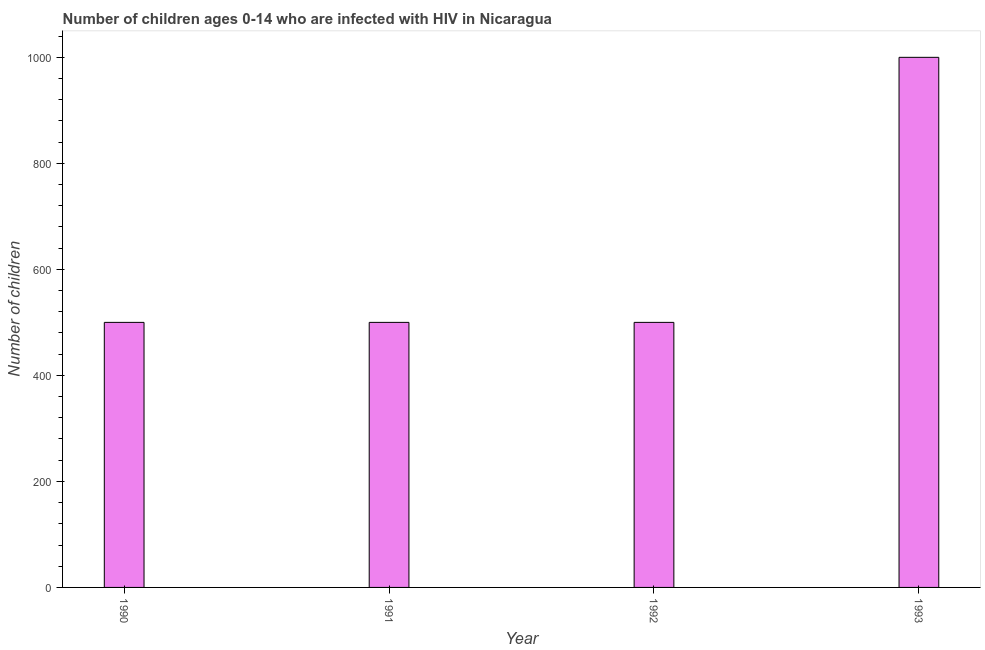Does the graph contain grids?
Keep it short and to the point. No. What is the title of the graph?
Provide a succinct answer. Number of children ages 0-14 who are infected with HIV in Nicaragua. What is the label or title of the Y-axis?
Your answer should be very brief. Number of children. What is the number of children living with hiv in 1991?
Ensure brevity in your answer.  500. Across all years, what is the minimum number of children living with hiv?
Your answer should be compact. 500. What is the sum of the number of children living with hiv?
Provide a succinct answer. 2500. What is the difference between the number of children living with hiv in 1991 and 1992?
Ensure brevity in your answer.  0. What is the average number of children living with hiv per year?
Keep it short and to the point. 625. What is the median number of children living with hiv?
Your response must be concise. 500. Do a majority of the years between 1991 and 1990 (inclusive) have number of children living with hiv greater than 960 ?
Your answer should be compact. No. Is the difference between the number of children living with hiv in 1990 and 1991 greater than the difference between any two years?
Your answer should be compact. No. What is the difference between the highest and the second highest number of children living with hiv?
Your answer should be compact. 500. Is the sum of the number of children living with hiv in 1991 and 1993 greater than the maximum number of children living with hiv across all years?
Give a very brief answer. Yes. What is the difference between the highest and the lowest number of children living with hiv?
Give a very brief answer. 500. How many bars are there?
Give a very brief answer. 4. Are all the bars in the graph horizontal?
Offer a terse response. No. What is the difference between two consecutive major ticks on the Y-axis?
Keep it short and to the point. 200. Are the values on the major ticks of Y-axis written in scientific E-notation?
Offer a very short reply. No. What is the Number of children in 1990?
Offer a terse response. 500. What is the Number of children of 1991?
Ensure brevity in your answer.  500. What is the Number of children of 1992?
Ensure brevity in your answer.  500. What is the difference between the Number of children in 1990 and 1993?
Offer a very short reply. -500. What is the difference between the Number of children in 1991 and 1993?
Offer a very short reply. -500. What is the difference between the Number of children in 1992 and 1993?
Give a very brief answer. -500. What is the ratio of the Number of children in 1990 to that in 1992?
Your answer should be compact. 1. 